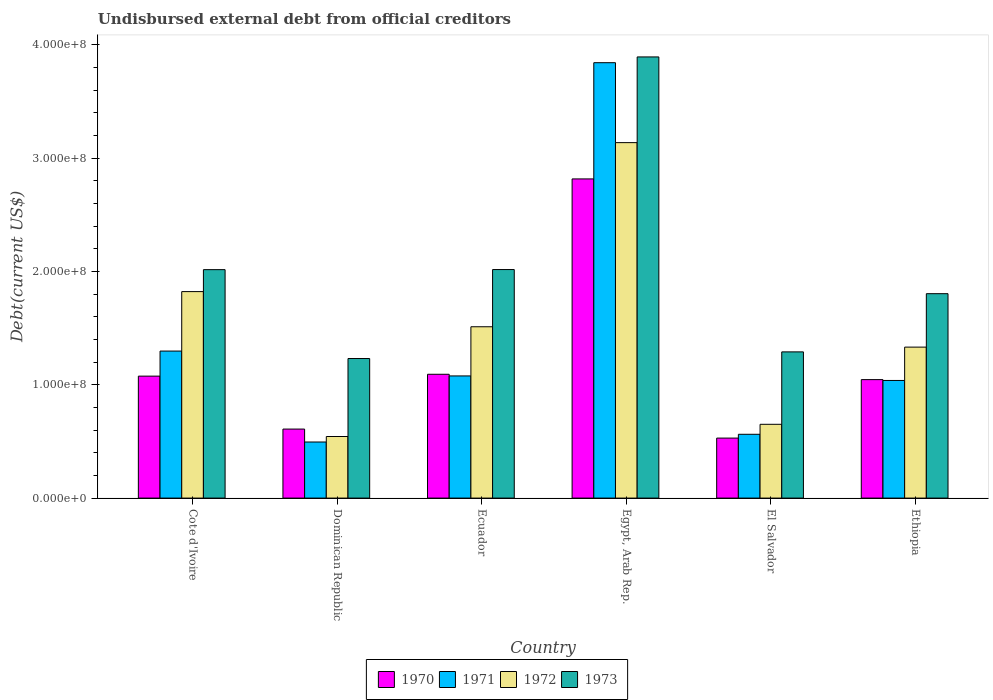How many groups of bars are there?
Ensure brevity in your answer.  6. Are the number of bars on each tick of the X-axis equal?
Your answer should be very brief. Yes. How many bars are there on the 3rd tick from the right?
Offer a very short reply. 4. What is the label of the 4th group of bars from the left?
Keep it short and to the point. Egypt, Arab Rep. In how many cases, is the number of bars for a given country not equal to the number of legend labels?
Provide a succinct answer. 0. What is the total debt in 1972 in El Salvador?
Your answer should be compact. 6.51e+07. Across all countries, what is the maximum total debt in 1970?
Your answer should be very brief. 2.82e+08. Across all countries, what is the minimum total debt in 1973?
Offer a very short reply. 1.23e+08. In which country was the total debt in 1973 maximum?
Keep it short and to the point. Egypt, Arab Rep. In which country was the total debt in 1972 minimum?
Give a very brief answer. Dominican Republic. What is the total total debt in 1972 in the graph?
Provide a short and direct response. 9.00e+08. What is the difference between the total debt in 1972 in Cote d'Ivoire and that in Ethiopia?
Ensure brevity in your answer.  4.90e+07. What is the difference between the total debt in 1971 in Cote d'Ivoire and the total debt in 1972 in Dominican Republic?
Keep it short and to the point. 7.54e+07. What is the average total debt in 1972 per country?
Your response must be concise. 1.50e+08. What is the difference between the total debt of/in 1972 and total debt of/in 1970 in Dominican Republic?
Your answer should be compact. -6.57e+06. What is the ratio of the total debt in 1971 in Cote d'Ivoire to that in Ethiopia?
Give a very brief answer. 1.25. Is the total debt in 1971 in Ecuador less than that in El Salvador?
Ensure brevity in your answer.  No. What is the difference between the highest and the second highest total debt in 1970?
Offer a very short reply. 1.74e+08. What is the difference between the highest and the lowest total debt in 1973?
Make the answer very short. 2.66e+08. In how many countries, is the total debt in 1972 greater than the average total debt in 1972 taken over all countries?
Your answer should be compact. 3. Is it the case that in every country, the sum of the total debt in 1970 and total debt in 1972 is greater than the sum of total debt in 1973 and total debt in 1971?
Keep it short and to the point. No. What does the 4th bar from the left in Dominican Republic represents?
Offer a terse response. 1973. Is it the case that in every country, the sum of the total debt in 1973 and total debt in 1970 is greater than the total debt in 1972?
Your response must be concise. Yes. Are all the bars in the graph horizontal?
Give a very brief answer. No. Does the graph contain grids?
Keep it short and to the point. No. Where does the legend appear in the graph?
Your response must be concise. Bottom center. How many legend labels are there?
Your answer should be very brief. 4. How are the legend labels stacked?
Your answer should be very brief. Horizontal. What is the title of the graph?
Your response must be concise. Undisbursed external debt from official creditors. What is the label or title of the X-axis?
Offer a terse response. Country. What is the label or title of the Y-axis?
Make the answer very short. Debt(current US$). What is the Debt(current US$) of 1970 in Cote d'Ivoire?
Make the answer very short. 1.08e+08. What is the Debt(current US$) of 1971 in Cote d'Ivoire?
Offer a terse response. 1.30e+08. What is the Debt(current US$) of 1972 in Cote d'Ivoire?
Your response must be concise. 1.82e+08. What is the Debt(current US$) of 1973 in Cote d'Ivoire?
Make the answer very short. 2.02e+08. What is the Debt(current US$) in 1970 in Dominican Republic?
Ensure brevity in your answer.  6.09e+07. What is the Debt(current US$) in 1971 in Dominican Republic?
Keep it short and to the point. 4.95e+07. What is the Debt(current US$) of 1972 in Dominican Republic?
Provide a succinct answer. 5.44e+07. What is the Debt(current US$) in 1973 in Dominican Republic?
Keep it short and to the point. 1.23e+08. What is the Debt(current US$) of 1970 in Ecuador?
Make the answer very short. 1.09e+08. What is the Debt(current US$) in 1971 in Ecuador?
Make the answer very short. 1.08e+08. What is the Debt(current US$) of 1972 in Ecuador?
Your response must be concise. 1.51e+08. What is the Debt(current US$) of 1973 in Ecuador?
Your answer should be compact. 2.02e+08. What is the Debt(current US$) of 1970 in Egypt, Arab Rep.?
Your answer should be very brief. 2.82e+08. What is the Debt(current US$) in 1971 in Egypt, Arab Rep.?
Offer a very short reply. 3.84e+08. What is the Debt(current US$) in 1972 in Egypt, Arab Rep.?
Provide a succinct answer. 3.14e+08. What is the Debt(current US$) in 1973 in Egypt, Arab Rep.?
Ensure brevity in your answer.  3.89e+08. What is the Debt(current US$) in 1970 in El Salvador?
Ensure brevity in your answer.  5.30e+07. What is the Debt(current US$) in 1971 in El Salvador?
Keep it short and to the point. 5.63e+07. What is the Debt(current US$) of 1972 in El Salvador?
Offer a very short reply. 6.51e+07. What is the Debt(current US$) in 1973 in El Salvador?
Keep it short and to the point. 1.29e+08. What is the Debt(current US$) of 1970 in Ethiopia?
Offer a very short reply. 1.05e+08. What is the Debt(current US$) in 1971 in Ethiopia?
Provide a short and direct response. 1.04e+08. What is the Debt(current US$) in 1972 in Ethiopia?
Make the answer very short. 1.33e+08. What is the Debt(current US$) in 1973 in Ethiopia?
Give a very brief answer. 1.80e+08. Across all countries, what is the maximum Debt(current US$) of 1970?
Provide a succinct answer. 2.82e+08. Across all countries, what is the maximum Debt(current US$) of 1971?
Your answer should be compact. 3.84e+08. Across all countries, what is the maximum Debt(current US$) in 1972?
Provide a succinct answer. 3.14e+08. Across all countries, what is the maximum Debt(current US$) of 1973?
Your answer should be very brief. 3.89e+08. Across all countries, what is the minimum Debt(current US$) of 1970?
Keep it short and to the point. 5.30e+07. Across all countries, what is the minimum Debt(current US$) in 1971?
Give a very brief answer. 4.95e+07. Across all countries, what is the minimum Debt(current US$) of 1972?
Offer a terse response. 5.44e+07. Across all countries, what is the minimum Debt(current US$) of 1973?
Ensure brevity in your answer.  1.23e+08. What is the total Debt(current US$) of 1970 in the graph?
Offer a terse response. 7.17e+08. What is the total Debt(current US$) of 1971 in the graph?
Offer a terse response. 8.32e+08. What is the total Debt(current US$) of 1972 in the graph?
Make the answer very short. 9.00e+08. What is the total Debt(current US$) in 1973 in the graph?
Your response must be concise. 1.23e+09. What is the difference between the Debt(current US$) of 1970 in Cote d'Ivoire and that in Dominican Republic?
Offer a very short reply. 4.67e+07. What is the difference between the Debt(current US$) in 1971 in Cote d'Ivoire and that in Dominican Republic?
Give a very brief answer. 8.03e+07. What is the difference between the Debt(current US$) of 1972 in Cote d'Ivoire and that in Dominican Republic?
Give a very brief answer. 1.28e+08. What is the difference between the Debt(current US$) in 1973 in Cote d'Ivoire and that in Dominican Republic?
Give a very brief answer. 7.84e+07. What is the difference between the Debt(current US$) of 1970 in Cote d'Ivoire and that in Ecuador?
Your answer should be compact. -1.64e+06. What is the difference between the Debt(current US$) of 1971 in Cote d'Ivoire and that in Ecuador?
Your answer should be compact. 2.19e+07. What is the difference between the Debt(current US$) in 1972 in Cote d'Ivoire and that in Ecuador?
Provide a succinct answer. 3.10e+07. What is the difference between the Debt(current US$) of 1973 in Cote d'Ivoire and that in Ecuador?
Your response must be concise. -8.40e+04. What is the difference between the Debt(current US$) of 1970 in Cote d'Ivoire and that in Egypt, Arab Rep.?
Your answer should be very brief. -1.74e+08. What is the difference between the Debt(current US$) of 1971 in Cote d'Ivoire and that in Egypt, Arab Rep.?
Provide a short and direct response. -2.55e+08. What is the difference between the Debt(current US$) of 1972 in Cote d'Ivoire and that in Egypt, Arab Rep.?
Make the answer very short. -1.31e+08. What is the difference between the Debt(current US$) of 1973 in Cote d'Ivoire and that in Egypt, Arab Rep.?
Provide a succinct answer. -1.88e+08. What is the difference between the Debt(current US$) in 1970 in Cote d'Ivoire and that in El Salvador?
Offer a very short reply. 5.47e+07. What is the difference between the Debt(current US$) of 1971 in Cote d'Ivoire and that in El Salvador?
Offer a terse response. 7.35e+07. What is the difference between the Debt(current US$) of 1972 in Cote d'Ivoire and that in El Salvador?
Your response must be concise. 1.17e+08. What is the difference between the Debt(current US$) in 1973 in Cote d'Ivoire and that in El Salvador?
Offer a very short reply. 7.26e+07. What is the difference between the Debt(current US$) of 1970 in Cote d'Ivoire and that in Ethiopia?
Offer a terse response. 3.08e+06. What is the difference between the Debt(current US$) in 1971 in Cote d'Ivoire and that in Ethiopia?
Provide a succinct answer. 2.59e+07. What is the difference between the Debt(current US$) of 1972 in Cote d'Ivoire and that in Ethiopia?
Offer a very short reply. 4.90e+07. What is the difference between the Debt(current US$) of 1973 in Cote d'Ivoire and that in Ethiopia?
Offer a very short reply. 2.12e+07. What is the difference between the Debt(current US$) of 1970 in Dominican Republic and that in Ecuador?
Your answer should be very brief. -4.84e+07. What is the difference between the Debt(current US$) in 1971 in Dominican Republic and that in Ecuador?
Offer a very short reply. -5.83e+07. What is the difference between the Debt(current US$) of 1972 in Dominican Republic and that in Ecuador?
Keep it short and to the point. -9.69e+07. What is the difference between the Debt(current US$) in 1973 in Dominican Republic and that in Ecuador?
Offer a terse response. -7.85e+07. What is the difference between the Debt(current US$) in 1970 in Dominican Republic and that in Egypt, Arab Rep.?
Your response must be concise. -2.21e+08. What is the difference between the Debt(current US$) of 1971 in Dominican Republic and that in Egypt, Arab Rep.?
Give a very brief answer. -3.35e+08. What is the difference between the Debt(current US$) in 1972 in Dominican Republic and that in Egypt, Arab Rep.?
Provide a short and direct response. -2.59e+08. What is the difference between the Debt(current US$) of 1973 in Dominican Republic and that in Egypt, Arab Rep.?
Make the answer very short. -2.66e+08. What is the difference between the Debt(current US$) in 1970 in Dominican Republic and that in El Salvador?
Give a very brief answer. 7.96e+06. What is the difference between the Debt(current US$) of 1971 in Dominican Republic and that in El Salvador?
Your answer should be very brief. -6.81e+06. What is the difference between the Debt(current US$) of 1972 in Dominican Republic and that in El Salvador?
Your answer should be very brief. -1.08e+07. What is the difference between the Debt(current US$) in 1973 in Dominican Republic and that in El Salvador?
Ensure brevity in your answer.  -5.85e+06. What is the difference between the Debt(current US$) in 1970 in Dominican Republic and that in Ethiopia?
Your response must be concise. -4.36e+07. What is the difference between the Debt(current US$) in 1971 in Dominican Republic and that in Ethiopia?
Offer a terse response. -5.43e+07. What is the difference between the Debt(current US$) in 1972 in Dominican Republic and that in Ethiopia?
Your response must be concise. -7.89e+07. What is the difference between the Debt(current US$) of 1973 in Dominican Republic and that in Ethiopia?
Make the answer very short. -5.72e+07. What is the difference between the Debt(current US$) of 1970 in Ecuador and that in Egypt, Arab Rep.?
Your answer should be very brief. -1.72e+08. What is the difference between the Debt(current US$) in 1971 in Ecuador and that in Egypt, Arab Rep.?
Your answer should be compact. -2.76e+08. What is the difference between the Debt(current US$) in 1972 in Ecuador and that in Egypt, Arab Rep.?
Offer a terse response. -1.63e+08. What is the difference between the Debt(current US$) in 1973 in Ecuador and that in Egypt, Arab Rep.?
Provide a succinct answer. -1.88e+08. What is the difference between the Debt(current US$) in 1970 in Ecuador and that in El Salvador?
Make the answer very short. 5.63e+07. What is the difference between the Debt(current US$) of 1971 in Ecuador and that in El Salvador?
Provide a short and direct response. 5.15e+07. What is the difference between the Debt(current US$) of 1972 in Ecuador and that in El Salvador?
Offer a terse response. 8.61e+07. What is the difference between the Debt(current US$) of 1973 in Ecuador and that in El Salvador?
Your response must be concise. 7.27e+07. What is the difference between the Debt(current US$) of 1970 in Ecuador and that in Ethiopia?
Provide a short and direct response. 4.72e+06. What is the difference between the Debt(current US$) of 1971 in Ecuador and that in Ethiopia?
Your answer should be compact. 4.00e+06. What is the difference between the Debt(current US$) of 1972 in Ecuador and that in Ethiopia?
Provide a short and direct response. 1.80e+07. What is the difference between the Debt(current US$) in 1973 in Ecuador and that in Ethiopia?
Your answer should be very brief. 2.13e+07. What is the difference between the Debt(current US$) of 1970 in Egypt, Arab Rep. and that in El Salvador?
Give a very brief answer. 2.29e+08. What is the difference between the Debt(current US$) in 1971 in Egypt, Arab Rep. and that in El Salvador?
Give a very brief answer. 3.28e+08. What is the difference between the Debt(current US$) in 1972 in Egypt, Arab Rep. and that in El Salvador?
Provide a short and direct response. 2.49e+08. What is the difference between the Debt(current US$) of 1973 in Egypt, Arab Rep. and that in El Salvador?
Provide a short and direct response. 2.60e+08. What is the difference between the Debt(current US$) of 1970 in Egypt, Arab Rep. and that in Ethiopia?
Your response must be concise. 1.77e+08. What is the difference between the Debt(current US$) in 1971 in Egypt, Arab Rep. and that in Ethiopia?
Ensure brevity in your answer.  2.80e+08. What is the difference between the Debt(current US$) in 1972 in Egypt, Arab Rep. and that in Ethiopia?
Give a very brief answer. 1.80e+08. What is the difference between the Debt(current US$) of 1973 in Egypt, Arab Rep. and that in Ethiopia?
Your answer should be very brief. 2.09e+08. What is the difference between the Debt(current US$) in 1970 in El Salvador and that in Ethiopia?
Your answer should be compact. -5.16e+07. What is the difference between the Debt(current US$) of 1971 in El Salvador and that in Ethiopia?
Provide a succinct answer. -4.75e+07. What is the difference between the Debt(current US$) of 1972 in El Salvador and that in Ethiopia?
Your response must be concise. -6.81e+07. What is the difference between the Debt(current US$) of 1973 in El Salvador and that in Ethiopia?
Keep it short and to the point. -5.14e+07. What is the difference between the Debt(current US$) in 1970 in Cote d'Ivoire and the Debt(current US$) in 1971 in Dominican Republic?
Make the answer very short. 5.81e+07. What is the difference between the Debt(current US$) in 1970 in Cote d'Ivoire and the Debt(current US$) in 1972 in Dominican Republic?
Keep it short and to the point. 5.33e+07. What is the difference between the Debt(current US$) of 1970 in Cote d'Ivoire and the Debt(current US$) of 1973 in Dominican Republic?
Provide a short and direct response. -1.55e+07. What is the difference between the Debt(current US$) in 1971 in Cote d'Ivoire and the Debt(current US$) in 1972 in Dominican Republic?
Offer a terse response. 7.54e+07. What is the difference between the Debt(current US$) in 1971 in Cote d'Ivoire and the Debt(current US$) in 1973 in Dominican Republic?
Your response must be concise. 6.57e+06. What is the difference between the Debt(current US$) in 1972 in Cote d'Ivoire and the Debt(current US$) in 1973 in Dominican Republic?
Your response must be concise. 5.91e+07. What is the difference between the Debt(current US$) in 1970 in Cote d'Ivoire and the Debt(current US$) in 1971 in Ecuador?
Your answer should be very brief. -1.73e+05. What is the difference between the Debt(current US$) in 1970 in Cote d'Ivoire and the Debt(current US$) in 1972 in Ecuador?
Offer a terse response. -4.36e+07. What is the difference between the Debt(current US$) in 1970 in Cote d'Ivoire and the Debt(current US$) in 1973 in Ecuador?
Provide a succinct answer. -9.41e+07. What is the difference between the Debt(current US$) in 1971 in Cote d'Ivoire and the Debt(current US$) in 1972 in Ecuador?
Keep it short and to the point. -2.15e+07. What is the difference between the Debt(current US$) of 1971 in Cote d'Ivoire and the Debt(current US$) of 1973 in Ecuador?
Your answer should be compact. -7.20e+07. What is the difference between the Debt(current US$) in 1972 in Cote d'Ivoire and the Debt(current US$) in 1973 in Ecuador?
Make the answer very short. -1.95e+07. What is the difference between the Debt(current US$) in 1970 in Cote d'Ivoire and the Debt(current US$) in 1971 in Egypt, Arab Rep.?
Provide a succinct answer. -2.77e+08. What is the difference between the Debt(current US$) of 1970 in Cote d'Ivoire and the Debt(current US$) of 1972 in Egypt, Arab Rep.?
Make the answer very short. -2.06e+08. What is the difference between the Debt(current US$) in 1970 in Cote d'Ivoire and the Debt(current US$) in 1973 in Egypt, Arab Rep.?
Make the answer very short. -2.82e+08. What is the difference between the Debt(current US$) of 1971 in Cote d'Ivoire and the Debt(current US$) of 1972 in Egypt, Arab Rep.?
Provide a succinct answer. -1.84e+08. What is the difference between the Debt(current US$) of 1971 in Cote d'Ivoire and the Debt(current US$) of 1973 in Egypt, Arab Rep.?
Provide a succinct answer. -2.60e+08. What is the difference between the Debt(current US$) in 1972 in Cote d'Ivoire and the Debt(current US$) in 1973 in Egypt, Arab Rep.?
Offer a very short reply. -2.07e+08. What is the difference between the Debt(current US$) in 1970 in Cote d'Ivoire and the Debt(current US$) in 1971 in El Salvador?
Give a very brief answer. 5.13e+07. What is the difference between the Debt(current US$) in 1970 in Cote d'Ivoire and the Debt(current US$) in 1972 in El Salvador?
Offer a terse response. 4.25e+07. What is the difference between the Debt(current US$) of 1970 in Cote d'Ivoire and the Debt(current US$) of 1973 in El Salvador?
Give a very brief answer. -2.14e+07. What is the difference between the Debt(current US$) in 1971 in Cote d'Ivoire and the Debt(current US$) in 1972 in El Salvador?
Keep it short and to the point. 6.46e+07. What is the difference between the Debt(current US$) in 1971 in Cote d'Ivoire and the Debt(current US$) in 1973 in El Salvador?
Keep it short and to the point. 7.17e+05. What is the difference between the Debt(current US$) in 1972 in Cote d'Ivoire and the Debt(current US$) in 1973 in El Salvador?
Keep it short and to the point. 5.32e+07. What is the difference between the Debt(current US$) of 1970 in Cote d'Ivoire and the Debt(current US$) of 1971 in Ethiopia?
Offer a terse response. 3.83e+06. What is the difference between the Debt(current US$) in 1970 in Cote d'Ivoire and the Debt(current US$) in 1972 in Ethiopia?
Make the answer very short. -2.56e+07. What is the difference between the Debt(current US$) in 1970 in Cote d'Ivoire and the Debt(current US$) in 1973 in Ethiopia?
Offer a very short reply. -7.28e+07. What is the difference between the Debt(current US$) in 1971 in Cote d'Ivoire and the Debt(current US$) in 1972 in Ethiopia?
Your answer should be very brief. -3.50e+06. What is the difference between the Debt(current US$) of 1971 in Cote d'Ivoire and the Debt(current US$) of 1973 in Ethiopia?
Give a very brief answer. -5.07e+07. What is the difference between the Debt(current US$) in 1972 in Cote d'Ivoire and the Debt(current US$) in 1973 in Ethiopia?
Your answer should be very brief. 1.84e+06. What is the difference between the Debt(current US$) of 1970 in Dominican Republic and the Debt(current US$) of 1971 in Ecuador?
Give a very brief answer. -4.69e+07. What is the difference between the Debt(current US$) of 1970 in Dominican Republic and the Debt(current US$) of 1972 in Ecuador?
Provide a succinct answer. -9.03e+07. What is the difference between the Debt(current US$) of 1970 in Dominican Republic and the Debt(current US$) of 1973 in Ecuador?
Give a very brief answer. -1.41e+08. What is the difference between the Debt(current US$) of 1971 in Dominican Republic and the Debt(current US$) of 1972 in Ecuador?
Make the answer very short. -1.02e+08. What is the difference between the Debt(current US$) in 1971 in Dominican Republic and the Debt(current US$) in 1973 in Ecuador?
Your response must be concise. -1.52e+08. What is the difference between the Debt(current US$) of 1972 in Dominican Republic and the Debt(current US$) of 1973 in Ecuador?
Give a very brief answer. -1.47e+08. What is the difference between the Debt(current US$) in 1970 in Dominican Republic and the Debt(current US$) in 1971 in Egypt, Arab Rep.?
Offer a terse response. -3.23e+08. What is the difference between the Debt(current US$) in 1970 in Dominican Republic and the Debt(current US$) in 1972 in Egypt, Arab Rep.?
Your response must be concise. -2.53e+08. What is the difference between the Debt(current US$) in 1970 in Dominican Republic and the Debt(current US$) in 1973 in Egypt, Arab Rep.?
Make the answer very short. -3.28e+08. What is the difference between the Debt(current US$) of 1971 in Dominican Republic and the Debt(current US$) of 1972 in Egypt, Arab Rep.?
Make the answer very short. -2.64e+08. What is the difference between the Debt(current US$) of 1971 in Dominican Republic and the Debt(current US$) of 1973 in Egypt, Arab Rep.?
Ensure brevity in your answer.  -3.40e+08. What is the difference between the Debt(current US$) of 1972 in Dominican Republic and the Debt(current US$) of 1973 in Egypt, Arab Rep.?
Your answer should be very brief. -3.35e+08. What is the difference between the Debt(current US$) of 1970 in Dominican Republic and the Debt(current US$) of 1971 in El Salvador?
Your answer should be compact. 4.62e+06. What is the difference between the Debt(current US$) in 1970 in Dominican Republic and the Debt(current US$) in 1972 in El Salvador?
Offer a very short reply. -4.20e+06. What is the difference between the Debt(current US$) in 1970 in Dominican Republic and the Debt(current US$) in 1973 in El Salvador?
Give a very brief answer. -6.81e+07. What is the difference between the Debt(current US$) of 1971 in Dominican Republic and the Debt(current US$) of 1972 in El Salvador?
Make the answer very short. -1.56e+07. What is the difference between the Debt(current US$) of 1971 in Dominican Republic and the Debt(current US$) of 1973 in El Salvador?
Provide a succinct answer. -7.95e+07. What is the difference between the Debt(current US$) in 1972 in Dominican Republic and the Debt(current US$) in 1973 in El Salvador?
Provide a short and direct response. -7.47e+07. What is the difference between the Debt(current US$) in 1970 in Dominican Republic and the Debt(current US$) in 1971 in Ethiopia?
Your response must be concise. -4.29e+07. What is the difference between the Debt(current US$) of 1970 in Dominican Republic and the Debt(current US$) of 1972 in Ethiopia?
Your answer should be compact. -7.23e+07. What is the difference between the Debt(current US$) of 1970 in Dominican Republic and the Debt(current US$) of 1973 in Ethiopia?
Offer a very short reply. -1.20e+08. What is the difference between the Debt(current US$) of 1971 in Dominican Republic and the Debt(current US$) of 1972 in Ethiopia?
Provide a succinct answer. -8.38e+07. What is the difference between the Debt(current US$) of 1971 in Dominican Republic and the Debt(current US$) of 1973 in Ethiopia?
Ensure brevity in your answer.  -1.31e+08. What is the difference between the Debt(current US$) in 1972 in Dominican Republic and the Debt(current US$) in 1973 in Ethiopia?
Provide a short and direct response. -1.26e+08. What is the difference between the Debt(current US$) in 1970 in Ecuador and the Debt(current US$) in 1971 in Egypt, Arab Rep.?
Provide a short and direct response. -2.75e+08. What is the difference between the Debt(current US$) of 1970 in Ecuador and the Debt(current US$) of 1972 in Egypt, Arab Rep.?
Offer a very short reply. -2.04e+08. What is the difference between the Debt(current US$) in 1970 in Ecuador and the Debt(current US$) in 1973 in Egypt, Arab Rep.?
Offer a very short reply. -2.80e+08. What is the difference between the Debt(current US$) in 1971 in Ecuador and the Debt(current US$) in 1972 in Egypt, Arab Rep.?
Your answer should be compact. -2.06e+08. What is the difference between the Debt(current US$) in 1971 in Ecuador and the Debt(current US$) in 1973 in Egypt, Arab Rep.?
Your answer should be very brief. -2.82e+08. What is the difference between the Debt(current US$) in 1972 in Ecuador and the Debt(current US$) in 1973 in Egypt, Arab Rep.?
Your answer should be compact. -2.38e+08. What is the difference between the Debt(current US$) in 1970 in Ecuador and the Debt(current US$) in 1971 in El Salvador?
Offer a very short reply. 5.30e+07. What is the difference between the Debt(current US$) in 1970 in Ecuador and the Debt(current US$) in 1972 in El Salvador?
Keep it short and to the point. 4.42e+07. What is the difference between the Debt(current US$) in 1970 in Ecuador and the Debt(current US$) in 1973 in El Salvador?
Provide a short and direct response. -1.98e+07. What is the difference between the Debt(current US$) of 1971 in Ecuador and the Debt(current US$) of 1972 in El Salvador?
Ensure brevity in your answer.  4.27e+07. What is the difference between the Debt(current US$) in 1971 in Ecuador and the Debt(current US$) in 1973 in El Salvador?
Keep it short and to the point. -2.12e+07. What is the difference between the Debt(current US$) in 1972 in Ecuador and the Debt(current US$) in 1973 in El Salvador?
Your response must be concise. 2.22e+07. What is the difference between the Debt(current US$) in 1970 in Ecuador and the Debt(current US$) in 1971 in Ethiopia?
Provide a short and direct response. 5.47e+06. What is the difference between the Debt(current US$) in 1970 in Ecuador and the Debt(current US$) in 1972 in Ethiopia?
Provide a short and direct response. -2.40e+07. What is the difference between the Debt(current US$) in 1970 in Ecuador and the Debt(current US$) in 1973 in Ethiopia?
Offer a terse response. -7.11e+07. What is the difference between the Debt(current US$) of 1971 in Ecuador and the Debt(current US$) of 1972 in Ethiopia?
Your answer should be compact. -2.54e+07. What is the difference between the Debt(current US$) in 1971 in Ecuador and the Debt(current US$) in 1973 in Ethiopia?
Offer a very short reply. -7.26e+07. What is the difference between the Debt(current US$) in 1972 in Ecuador and the Debt(current US$) in 1973 in Ethiopia?
Give a very brief answer. -2.92e+07. What is the difference between the Debt(current US$) of 1970 in Egypt, Arab Rep. and the Debt(current US$) of 1971 in El Salvador?
Make the answer very short. 2.25e+08. What is the difference between the Debt(current US$) in 1970 in Egypt, Arab Rep. and the Debt(current US$) in 1972 in El Salvador?
Offer a very short reply. 2.17e+08. What is the difference between the Debt(current US$) of 1970 in Egypt, Arab Rep. and the Debt(current US$) of 1973 in El Salvador?
Offer a terse response. 1.53e+08. What is the difference between the Debt(current US$) of 1971 in Egypt, Arab Rep. and the Debt(current US$) of 1972 in El Salvador?
Keep it short and to the point. 3.19e+08. What is the difference between the Debt(current US$) of 1971 in Egypt, Arab Rep. and the Debt(current US$) of 1973 in El Salvador?
Ensure brevity in your answer.  2.55e+08. What is the difference between the Debt(current US$) of 1972 in Egypt, Arab Rep. and the Debt(current US$) of 1973 in El Salvador?
Offer a terse response. 1.85e+08. What is the difference between the Debt(current US$) of 1970 in Egypt, Arab Rep. and the Debt(current US$) of 1971 in Ethiopia?
Offer a very short reply. 1.78e+08. What is the difference between the Debt(current US$) of 1970 in Egypt, Arab Rep. and the Debt(current US$) of 1972 in Ethiopia?
Ensure brevity in your answer.  1.48e+08. What is the difference between the Debt(current US$) in 1970 in Egypt, Arab Rep. and the Debt(current US$) in 1973 in Ethiopia?
Make the answer very short. 1.01e+08. What is the difference between the Debt(current US$) of 1971 in Egypt, Arab Rep. and the Debt(current US$) of 1972 in Ethiopia?
Ensure brevity in your answer.  2.51e+08. What is the difference between the Debt(current US$) of 1971 in Egypt, Arab Rep. and the Debt(current US$) of 1973 in Ethiopia?
Make the answer very short. 2.04e+08. What is the difference between the Debt(current US$) of 1972 in Egypt, Arab Rep. and the Debt(current US$) of 1973 in Ethiopia?
Your response must be concise. 1.33e+08. What is the difference between the Debt(current US$) in 1970 in El Salvador and the Debt(current US$) in 1971 in Ethiopia?
Give a very brief answer. -5.09e+07. What is the difference between the Debt(current US$) of 1970 in El Salvador and the Debt(current US$) of 1972 in Ethiopia?
Provide a short and direct response. -8.03e+07. What is the difference between the Debt(current US$) in 1970 in El Salvador and the Debt(current US$) in 1973 in Ethiopia?
Keep it short and to the point. -1.27e+08. What is the difference between the Debt(current US$) in 1971 in El Salvador and the Debt(current US$) in 1972 in Ethiopia?
Your answer should be very brief. -7.70e+07. What is the difference between the Debt(current US$) in 1971 in El Salvador and the Debt(current US$) in 1973 in Ethiopia?
Your answer should be compact. -1.24e+08. What is the difference between the Debt(current US$) in 1972 in El Salvador and the Debt(current US$) in 1973 in Ethiopia?
Ensure brevity in your answer.  -1.15e+08. What is the average Debt(current US$) in 1970 per country?
Provide a succinct answer. 1.20e+08. What is the average Debt(current US$) of 1971 per country?
Provide a succinct answer. 1.39e+08. What is the average Debt(current US$) in 1972 per country?
Provide a short and direct response. 1.50e+08. What is the average Debt(current US$) in 1973 per country?
Keep it short and to the point. 2.04e+08. What is the difference between the Debt(current US$) in 1970 and Debt(current US$) in 1971 in Cote d'Ivoire?
Keep it short and to the point. -2.21e+07. What is the difference between the Debt(current US$) in 1970 and Debt(current US$) in 1972 in Cote d'Ivoire?
Ensure brevity in your answer.  -7.46e+07. What is the difference between the Debt(current US$) in 1970 and Debt(current US$) in 1973 in Cote d'Ivoire?
Give a very brief answer. -9.40e+07. What is the difference between the Debt(current US$) in 1971 and Debt(current US$) in 1972 in Cote d'Ivoire?
Ensure brevity in your answer.  -5.25e+07. What is the difference between the Debt(current US$) of 1971 and Debt(current US$) of 1973 in Cote d'Ivoire?
Your response must be concise. -7.19e+07. What is the difference between the Debt(current US$) of 1972 and Debt(current US$) of 1973 in Cote d'Ivoire?
Give a very brief answer. -1.94e+07. What is the difference between the Debt(current US$) of 1970 and Debt(current US$) of 1971 in Dominican Republic?
Provide a short and direct response. 1.14e+07. What is the difference between the Debt(current US$) in 1970 and Debt(current US$) in 1972 in Dominican Republic?
Your response must be concise. 6.57e+06. What is the difference between the Debt(current US$) in 1970 and Debt(current US$) in 1973 in Dominican Republic?
Give a very brief answer. -6.23e+07. What is the difference between the Debt(current US$) in 1971 and Debt(current US$) in 1972 in Dominican Republic?
Provide a short and direct response. -4.85e+06. What is the difference between the Debt(current US$) of 1971 and Debt(current US$) of 1973 in Dominican Republic?
Make the answer very short. -7.37e+07. What is the difference between the Debt(current US$) in 1972 and Debt(current US$) in 1973 in Dominican Republic?
Keep it short and to the point. -6.88e+07. What is the difference between the Debt(current US$) in 1970 and Debt(current US$) in 1971 in Ecuador?
Give a very brief answer. 1.47e+06. What is the difference between the Debt(current US$) in 1970 and Debt(current US$) in 1972 in Ecuador?
Offer a very short reply. -4.19e+07. What is the difference between the Debt(current US$) of 1970 and Debt(current US$) of 1973 in Ecuador?
Your answer should be very brief. -9.24e+07. What is the difference between the Debt(current US$) of 1971 and Debt(current US$) of 1972 in Ecuador?
Keep it short and to the point. -4.34e+07. What is the difference between the Debt(current US$) in 1971 and Debt(current US$) in 1973 in Ecuador?
Your answer should be compact. -9.39e+07. What is the difference between the Debt(current US$) in 1972 and Debt(current US$) in 1973 in Ecuador?
Offer a very short reply. -5.05e+07. What is the difference between the Debt(current US$) in 1970 and Debt(current US$) in 1971 in Egypt, Arab Rep.?
Keep it short and to the point. -1.03e+08. What is the difference between the Debt(current US$) in 1970 and Debt(current US$) in 1972 in Egypt, Arab Rep.?
Provide a succinct answer. -3.20e+07. What is the difference between the Debt(current US$) in 1970 and Debt(current US$) in 1973 in Egypt, Arab Rep.?
Ensure brevity in your answer.  -1.08e+08. What is the difference between the Debt(current US$) of 1971 and Debt(current US$) of 1972 in Egypt, Arab Rep.?
Your answer should be compact. 7.06e+07. What is the difference between the Debt(current US$) of 1971 and Debt(current US$) of 1973 in Egypt, Arab Rep.?
Your answer should be compact. -5.09e+06. What is the difference between the Debt(current US$) in 1972 and Debt(current US$) in 1973 in Egypt, Arab Rep.?
Ensure brevity in your answer.  -7.56e+07. What is the difference between the Debt(current US$) of 1970 and Debt(current US$) of 1971 in El Salvador?
Provide a short and direct response. -3.35e+06. What is the difference between the Debt(current US$) of 1970 and Debt(current US$) of 1972 in El Salvador?
Your answer should be compact. -1.22e+07. What is the difference between the Debt(current US$) in 1970 and Debt(current US$) in 1973 in El Salvador?
Provide a short and direct response. -7.61e+07. What is the difference between the Debt(current US$) of 1971 and Debt(current US$) of 1972 in El Salvador?
Offer a very short reply. -8.81e+06. What is the difference between the Debt(current US$) of 1971 and Debt(current US$) of 1973 in El Salvador?
Provide a short and direct response. -7.27e+07. What is the difference between the Debt(current US$) of 1972 and Debt(current US$) of 1973 in El Salvador?
Keep it short and to the point. -6.39e+07. What is the difference between the Debt(current US$) of 1970 and Debt(current US$) of 1971 in Ethiopia?
Provide a succinct answer. 7.54e+05. What is the difference between the Debt(current US$) in 1970 and Debt(current US$) in 1972 in Ethiopia?
Provide a short and direct response. -2.87e+07. What is the difference between the Debt(current US$) of 1970 and Debt(current US$) of 1973 in Ethiopia?
Offer a very short reply. -7.59e+07. What is the difference between the Debt(current US$) in 1971 and Debt(current US$) in 1972 in Ethiopia?
Offer a terse response. -2.94e+07. What is the difference between the Debt(current US$) in 1971 and Debt(current US$) in 1973 in Ethiopia?
Ensure brevity in your answer.  -7.66e+07. What is the difference between the Debt(current US$) of 1972 and Debt(current US$) of 1973 in Ethiopia?
Give a very brief answer. -4.72e+07. What is the ratio of the Debt(current US$) in 1970 in Cote d'Ivoire to that in Dominican Republic?
Your response must be concise. 1.77. What is the ratio of the Debt(current US$) in 1971 in Cote d'Ivoire to that in Dominican Republic?
Your answer should be very brief. 2.62. What is the ratio of the Debt(current US$) of 1972 in Cote d'Ivoire to that in Dominican Republic?
Give a very brief answer. 3.35. What is the ratio of the Debt(current US$) of 1973 in Cote d'Ivoire to that in Dominican Republic?
Offer a terse response. 1.64. What is the ratio of the Debt(current US$) of 1970 in Cote d'Ivoire to that in Ecuador?
Ensure brevity in your answer.  0.98. What is the ratio of the Debt(current US$) in 1971 in Cote d'Ivoire to that in Ecuador?
Provide a short and direct response. 1.2. What is the ratio of the Debt(current US$) of 1972 in Cote d'Ivoire to that in Ecuador?
Offer a terse response. 1.21. What is the ratio of the Debt(current US$) of 1973 in Cote d'Ivoire to that in Ecuador?
Offer a terse response. 1. What is the ratio of the Debt(current US$) of 1970 in Cote d'Ivoire to that in Egypt, Arab Rep.?
Give a very brief answer. 0.38. What is the ratio of the Debt(current US$) of 1971 in Cote d'Ivoire to that in Egypt, Arab Rep.?
Your response must be concise. 0.34. What is the ratio of the Debt(current US$) of 1972 in Cote d'Ivoire to that in Egypt, Arab Rep.?
Your response must be concise. 0.58. What is the ratio of the Debt(current US$) in 1973 in Cote d'Ivoire to that in Egypt, Arab Rep.?
Make the answer very short. 0.52. What is the ratio of the Debt(current US$) in 1970 in Cote d'Ivoire to that in El Salvador?
Ensure brevity in your answer.  2.03. What is the ratio of the Debt(current US$) of 1971 in Cote d'Ivoire to that in El Salvador?
Offer a terse response. 2.3. What is the ratio of the Debt(current US$) in 1972 in Cote d'Ivoire to that in El Salvador?
Your response must be concise. 2.8. What is the ratio of the Debt(current US$) in 1973 in Cote d'Ivoire to that in El Salvador?
Ensure brevity in your answer.  1.56. What is the ratio of the Debt(current US$) in 1970 in Cote d'Ivoire to that in Ethiopia?
Give a very brief answer. 1.03. What is the ratio of the Debt(current US$) of 1971 in Cote d'Ivoire to that in Ethiopia?
Offer a terse response. 1.25. What is the ratio of the Debt(current US$) in 1972 in Cote d'Ivoire to that in Ethiopia?
Your answer should be compact. 1.37. What is the ratio of the Debt(current US$) in 1973 in Cote d'Ivoire to that in Ethiopia?
Your response must be concise. 1.12. What is the ratio of the Debt(current US$) in 1970 in Dominican Republic to that in Ecuador?
Provide a succinct answer. 0.56. What is the ratio of the Debt(current US$) of 1971 in Dominican Republic to that in Ecuador?
Offer a terse response. 0.46. What is the ratio of the Debt(current US$) in 1972 in Dominican Republic to that in Ecuador?
Ensure brevity in your answer.  0.36. What is the ratio of the Debt(current US$) in 1973 in Dominican Republic to that in Ecuador?
Make the answer very short. 0.61. What is the ratio of the Debt(current US$) of 1970 in Dominican Republic to that in Egypt, Arab Rep.?
Keep it short and to the point. 0.22. What is the ratio of the Debt(current US$) in 1971 in Dominican Republic to that in Egypt, Arab Rep.?
Make the answer very short. 0.13. What is the ratio of the Debt(current US$) in 1972 in Dominican Republic to that in Egypt, Arab Rep.?
Make the answer very short. 0.17. What is the ratio of the Debt(current US$) of 1973 in Dominican Republic to that in Egypt, Arab Rep.?
Your response must be concise. 0.32. What is the ratio of the Debt(current US$) of 1970 in Dominican Republic to that in El Salvador?
Provide a succinct answer. 1.15. What is the ratio of the Debt(current US$) in 1971 in Dominican Republic to that in El Salvador?
Ensure brevity in your answer.  0.88. What is the ratio of the Debt(current US$) of 1972 in Dominican Republic to that in El Salvador?
Make the answer very short. 0.83. What is the ratio of the Debt(current US$) of 1973 in Dominican Republic to that in El Salvador?
Make the answer very short. 0.95. What is the ratio of the Debt(current US$) in 1970 in Dominican Republic to that in Ethiopia?
Give a very brief answer. 0.58. What is the ratio of the Debt(current US$) in 1971 in Dominican Republic to that in Ethiopia?
Offer a terse response. 0.48. What is the ratio of the Debt(current US$) of 1972 in Dominican Republic to that in Ethiopia?
Your answer should be compact. 0.41. What is the ratio of the Debt(current US$) of 1973 in Dominican Republic to that in Ethiopia?
Your response must be concise. 0.68. What is the ratio of the Debt(current US$) of 1970 in Ecuador to that in Egypt, Arab Rep.?
Make the answer very short. 0.39. What is the ratio of the Debt(current US$) in 1971 in Ecuador to that in Egypt, Arab Rep.?
Give a very brief answer. 0.28. What is the ratio of the Debt(current US$) of 1972 in Ecuador to that in Egypt, Arab Rep.?
Your answer should be compact. 0.48. What is the ratio of the Debt(current US$) in 1973 in Ecuador to that in Egypt, Arab Rep.?
Offer a very short reply. 0.52. What is the ratio of the Debt(current US$) in 1970 in Ecuador to that in El Salvador?
Offer a terse response. 2.06. What is the ratio of the Debt(current US$) in 1971 in Ecuador to that in El Salvador?
Make the answer very short. 1.91. What is the ratio of the Debt(current US$) of 1972 in Ecuador to that in El Salvador?
Provide a short and direct response. 2.32. What is the ratio of the Debt(current US$) in 1973 in Ecuador to that in El Salvador?
Give a very brief answer. 1.56. What is the ratio of the Debt(current US$) in 1970 in Ecuador to that in Ethiopia?
Your answer should be compact. 1.05. What is the ratio of the Debt(current US$) of 1971 in Ecuador to that in Ethiopia?
Offer a very short reply. 1.04. What is the ratio of the Debt(current US$) of 1972 in Ecuador to that in Ethiopia?
Make the answer very short. 1.13. What is the ratio of the Debt(current US$) in 1973 in Ecuador to that in Ethiopia?
Your answer should be compact. 1.12. What is the ratio of the Debt(current US$) in 1970 in Egypt, Arab Rep. to that in El Salvador?
Provide a short and direct response. 5.32. What is the ratio of the Debt(current US$) of 1971 in Egypt, Arab Rep. to that in El Salvador?
Provide a short and direct response. 6.82. What is the ratio of the Debt(current US$) in 1972 in Egypt, Arab Rep. to that in El Salvador?
Ensure brevity in your answer.  4.82. What is the ratio of the Debt(current US$) in 1973 in Egypt, Arab Rep. to that in El Salvador?
Ensure brevity in your answer.  3.02. What is the ratio of the Debt(current US$) of 1970 in Egypt, Arab Rep. to that in Ethiopia?
Give a very brief answer. 2.69. What is the ratio of the Debt(current US$) in 1971 in Egypt, Arab Rep. to that in Ethiopia?
Keep it short and to the point. 3.7. What is the ratio of the Debt(current US$) in 1972 in Egypt, Arab Rep. to that in Ethiopia?
Provide a short and direct response. 2.35. What is the ratio of the Debt(current US$) of 1973 in Egypt, Arab Rep. to that in Ethiopia?
Make the answer very short. 2.16. What is the ratio of the Debt(current US$) in 1970 in El Salvador to that in Ethiopia?
Provide a succinct answer. 0.51. What is the ratio of the Debt(current US$) of 1971 in El Salvador to that in Ethiopia?
Give a very brief answer. 0.54. What is the ratio of the Debt(current US$) in 1972 in El Salvador to that in Ethiopia?
Ensure brevity in your answer.  0.49. What is the ratio of the Debt(current US$) of 1973 in El Salvador to that in Ethiopia?
Keep it short and to the point. 0.72. What is the difference between the highest and the second highest Debt(current US$) of 1970?
Offer a terse response. 1.72e+08. What is the difference between the highest and the second highest Debt(current US$) of 1971?
Your answer should be compact. 2.55e+08. What is the difference between the highest and the second highest Debt(current US$) in 1972?
Keep it short and to the point. 1.31e+08. What is the difference between the highest and the second highest Debt(current US$) of 1973?
Ensure brevity in your answer.  1.88e+08. What is the difference between the highest and the lowest Debt(current US$) of 1970?
Provide a short and direct response. 2.29e+08. What is the difference between the highest and the lowest Debt(current US$) of 1971?
Provide a succinct answer. 3.35e+08. What is the difference between the highest and the lowest Debt(current US$) of 1972?
Your answer should be compact. 2.59e+08. What is the difference between the highest and the lowest Debt(current US$) in 1973?
Ensure brevity in your answer.  2.66e+08. 